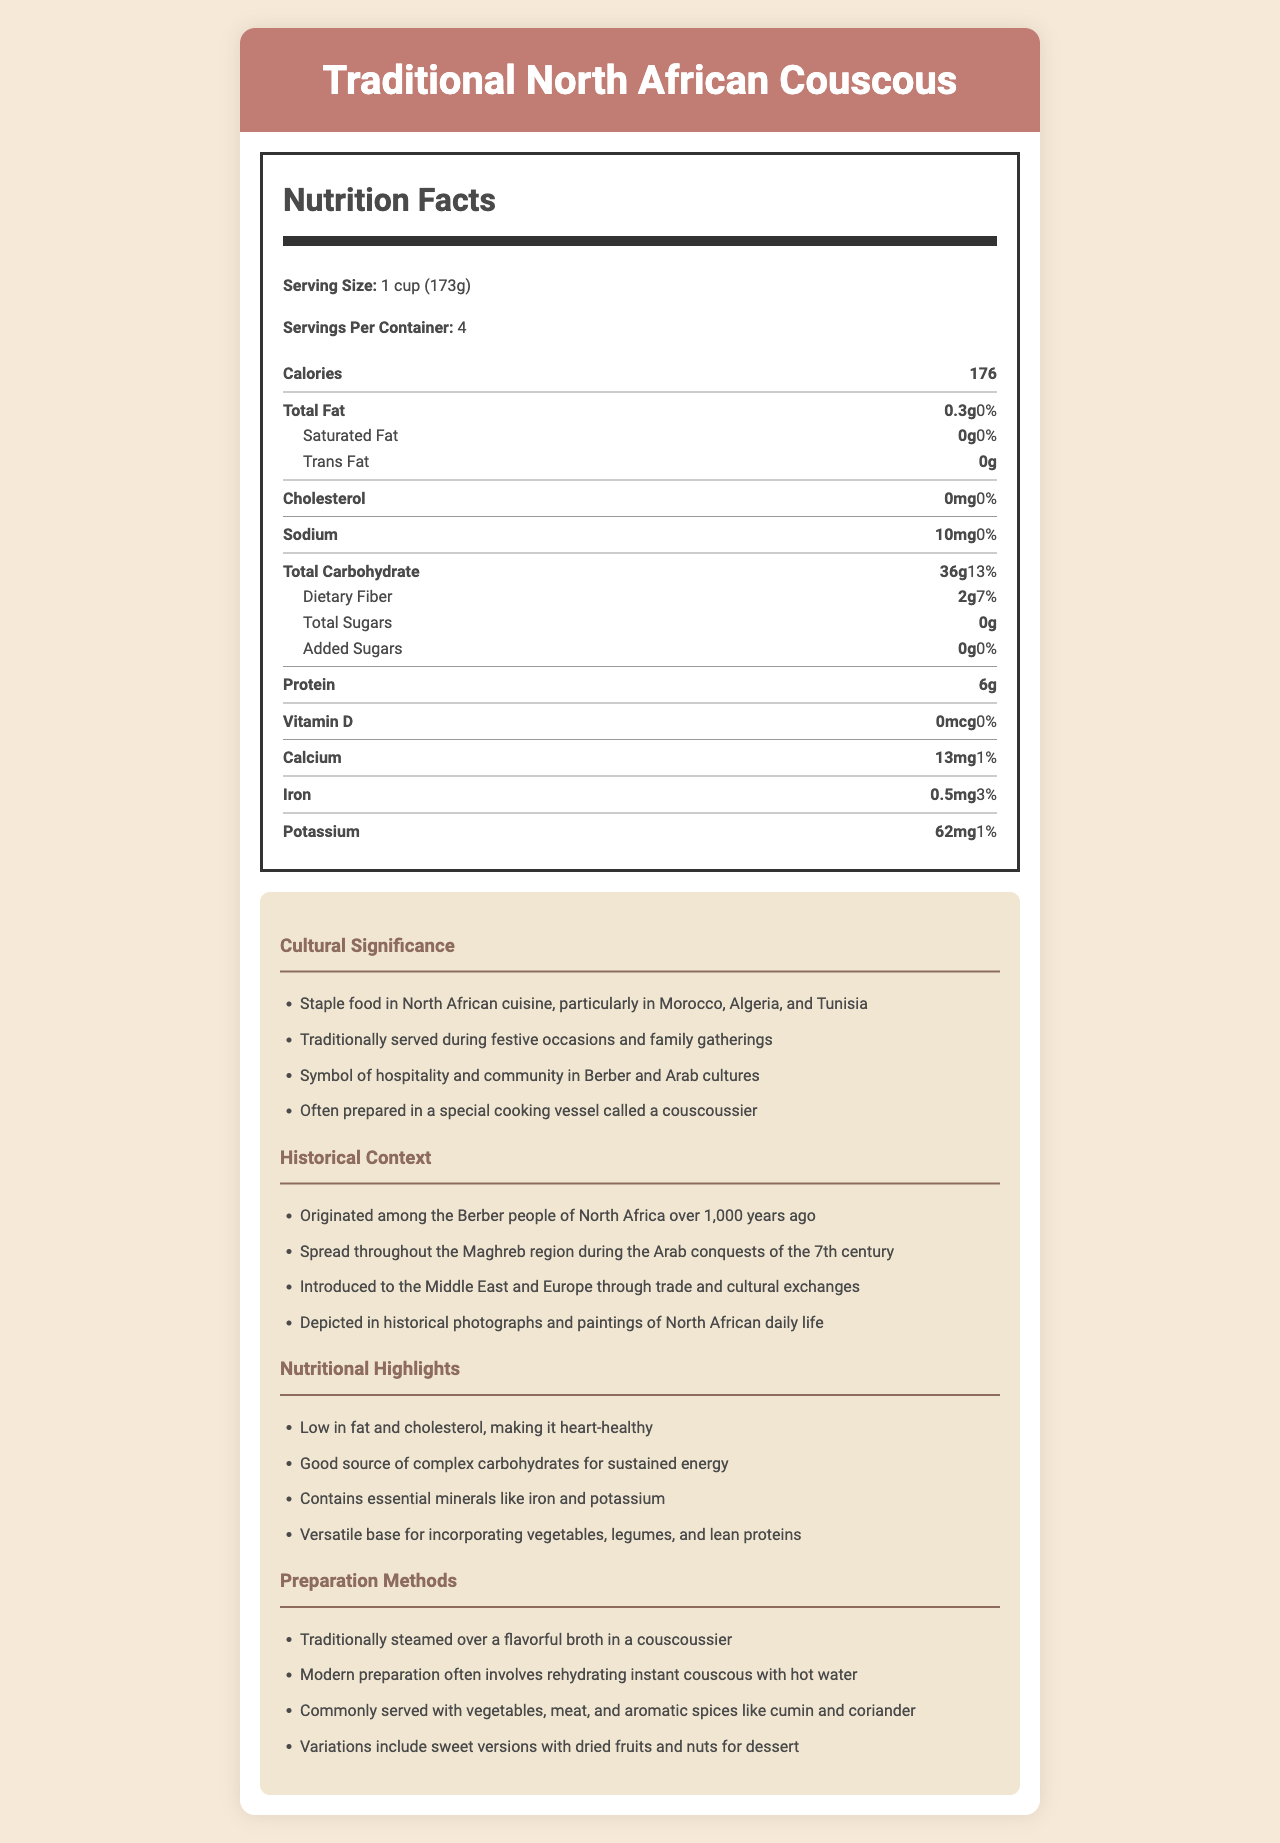what is the serving size for Traditional North African Couscous? The document specifies that the serving size for Traditional North African Couscous is 1 cup (173g).
Answer: 1 cup (173g) how many calories are there per serving? The nutrition label indicates that each serving contains 176 calories.
Answer: 176 what minerals are highlighted in the nutritional information? The nutritional highlights mention that Traditional North African Couscous contains essential minerals like iron and potassium.
Answer: Iron and Potassium what is the total amount of carbohydrates per serving? According to the document, one serving of couscous contains 36g of total carbohydrates.
Answer: 36g is Traditional North African Couscous high in protein? The document shows that there are 6g of protein per serving, which is a moderate amount but not considered high.
Answer: No what percentage of daily value does the total fat contribute? The total fat amount is 0.3g, which contributes 0% to the daily value.
Answer: 0% how is couscous traditionally prepared? The preparation methods highlight that couscous is traditionally steamed over a flavorful broth in a special cooking vessel called a couscoussier.
Answer: Steamed over a flavorful broth in a couscoussier which nutrient is present in the highest quantity based on the daily value percentage? A. Protein B. Dietary Fiber C. Total Carbohydrate D. Iron The document indicates that Total Carbohydrate has the highest daily value percentage at 13%.
Answer: C which of the following is NOT a cultural significance of couscous? A. Served during festive occasions and family gatherings B. Commonly eaten as a solo snack C. Symbol of hospitality and community D. Prepared in a special cooking vessel called a couscoussier The cultural significance section does not mention that couscous is commonly eaten as a solo snack.
Answer: B does couscous contain any added sugars? The nutrition label specifically states that there are 0g of added sugars.
Answer: No summarize the nutritional and cultural significance of Traditional North African Couscous. This summary captures key nutritional information such as the low-fat content and complex carbohydrates. It also highlights cultural practices, the traditional cooking method, and the importance of couscous in North African culture.
Answer: Traditional North African Couscous is a low-fat, cholesterol-free dish that is high in complex carbohydrates, contains essential minerals, and provides moderate protein. It holds cultural significance as a staple in North African cuisine, is served during festive occasions, symbolizes hospitality, and is traditionally prepared using a couscoussier. what is the potassium content per serving, and how does it contribute to the daily value? The document shows that each serving contains 62mg of potassium, which contributes 1% to the daily value.
Answer: 62mg, 1% how many servings are there per container? The document lists that there are 4 servings per container.
Answer: 4 does the Traditional North African Couscous provide any vitamin D? The nutrition label specifies that there is 0mcg of vitamin D in a serving.
Answer: No what are some of the historical contexts mentioned for couscous? The historical context section details these points about the history and spread of couscous.
Answer: Originated among the Berber people over 1,000 years ago, spread through the Maghreb during Arab conquests, introduced to Europe and the Middle East through trade, and depicted in historical photographs and paintings of North African daily life. where exactly can I find a couscoussier? The document explains the use of a couscoussier for preparing couscous but does not provide information on where to find one.
Answer: Not enough information 